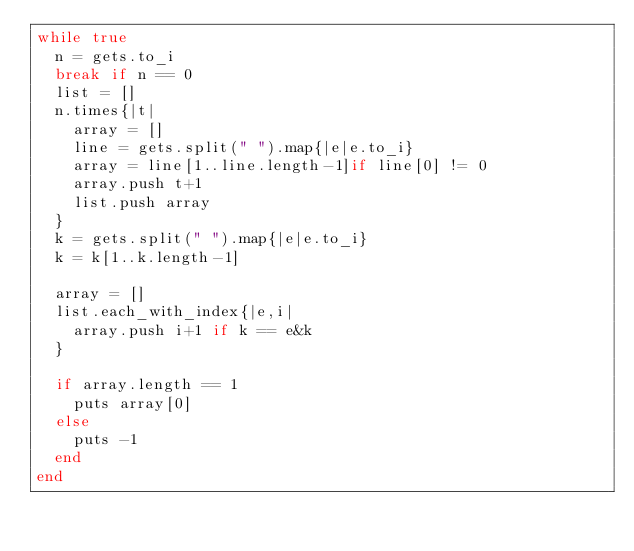<code> <loc_0><loc_0><loc_500><loc_500><_Ruby_>while true
  n = gets.to_i
  break if n == 0
  list = []
  n.times{|t|
    array = []
    line = gets.split(" ").map{|e|e.to_i}
    array = line[1..line.length-1]if line[0] != 0
    array.push t+1
    list.push array
  }
  k = gets.split(" ").map{|e|e.to_i}
  k = k[1..k.length-1]

  array = []
  list.each_with_index{|e,i|
    array.push i+1 if k == e&k
  }

  if array.length == 1
    puts array[0]
  else
    puts -1
  end
end</code> 